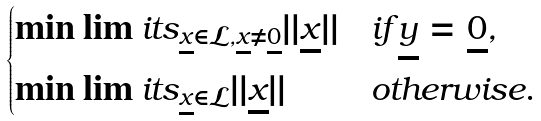<formula> <loc_0><loc_0><loc_500><loc_500>\begin{cases} \min \lim i t s _ { \underline { x } \in \mathcal { L } , \underline { x } \neq \underline { 0 } } | | \underline { x } | | & i f \underline { y } = \underline { 0 } , \\ \min \lim i t s _ { \underline { x } \in \mathcal { L } } | | \underline { x } | | & o t h e r w i s e . \end{cases}</formula> 